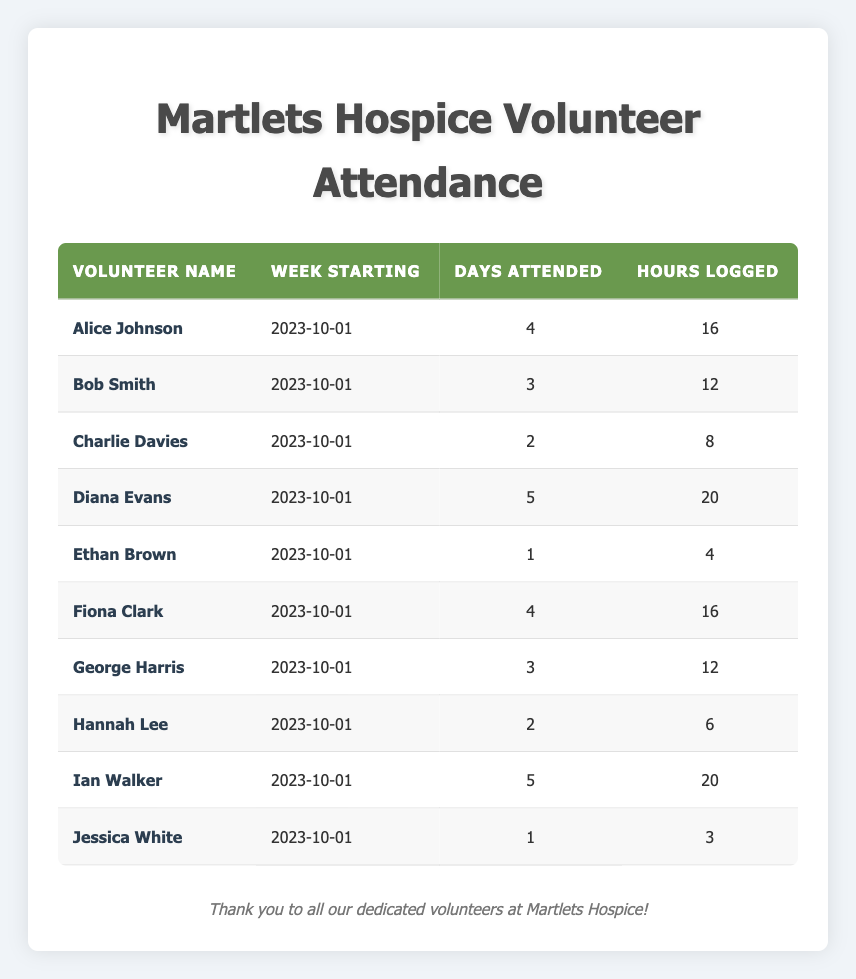What is the total number of hours logged by all volunteers? To find the total number of hours logged, we need to sum the hours logged by each volunteer: 16 + 12 + 8 + 20 + 4 + 16 + 12 + 6 + 20 + 3 = 117.
Answer: 117 How many days did Diana Evans attend? Diana Evans is listed in the table with 5 days attended.
Answer: 5 Which volunteer logged the fewest hours? Jessica White logged the fewest hours, which is 3.
Answer: 3 What is the average number of days attended by the volunteers? There are 10 volunteers, and their total days attended are 4 + 3 + 2 + 5 + 1 + 4 + 3 + 2 + 5 + 1 = 30. Thus, the average is 30 / 10 = 3.
Answer: 3 Did more than half of the volunteers attend at least 4 days? There are 10 volunteers; 6 volunteers attended at least 4 days (Alice Johnson, Diana Evans, Fiona Clark, Ian Walker). Since 6 is greater than half of 10 (which is 5), the answer is yes.
Answer: Yes How many volunteers logged 20 hours? From the table, both Diana Evans and Ian Walker logged 20 hours, so the total number of volunteers who logged 20 hours is 2.
Answer: 2 What is the difference in hours logged between the volunteer with the most hours and the volunteer with the least hours? The volunteer with the most hours is Diana Evans (20 hours) and the least is Jessica White (3 hours). The difference is 20 - 3 = 17 hours.
Answer: 17 How many volunteers attended exactly 2 days? Hannah Lee and Charlie Davies both attended exactly 2 days, so there are 2 volunteers who have this attendance.
Answer: 2 Which volunteer attended the most days and how many hours did they log? Diana Evans attended the most days with 5, and she logged 20 hours.
Answer: 5 days and 20 hours 